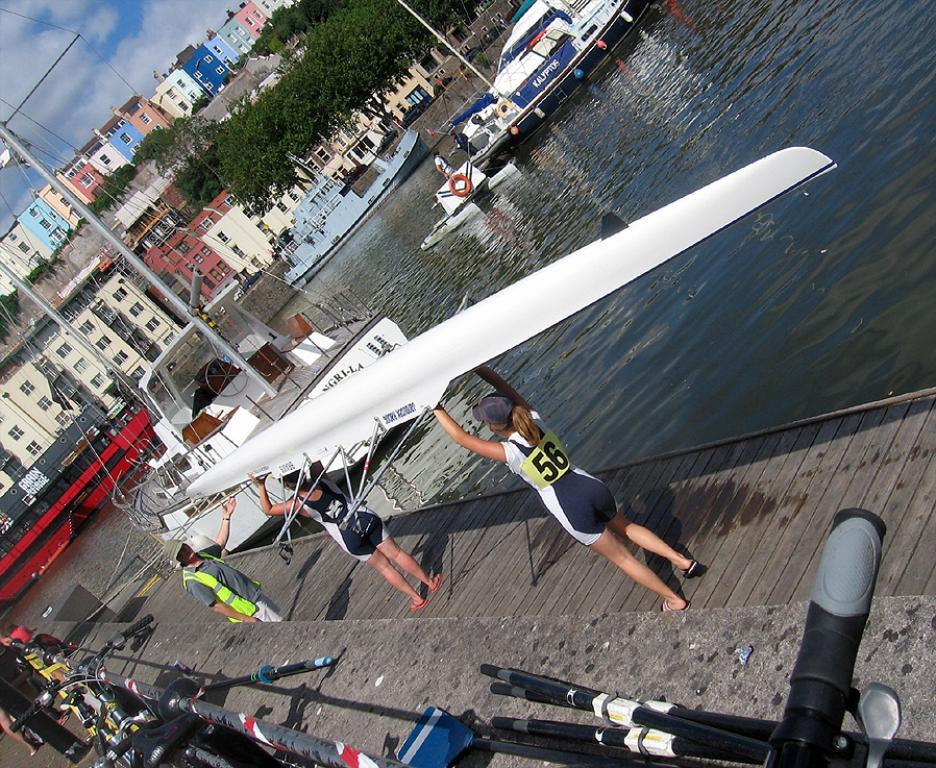<image>
Write a terse but informative summary of the picture. the numbers 56 are on the back of the person 